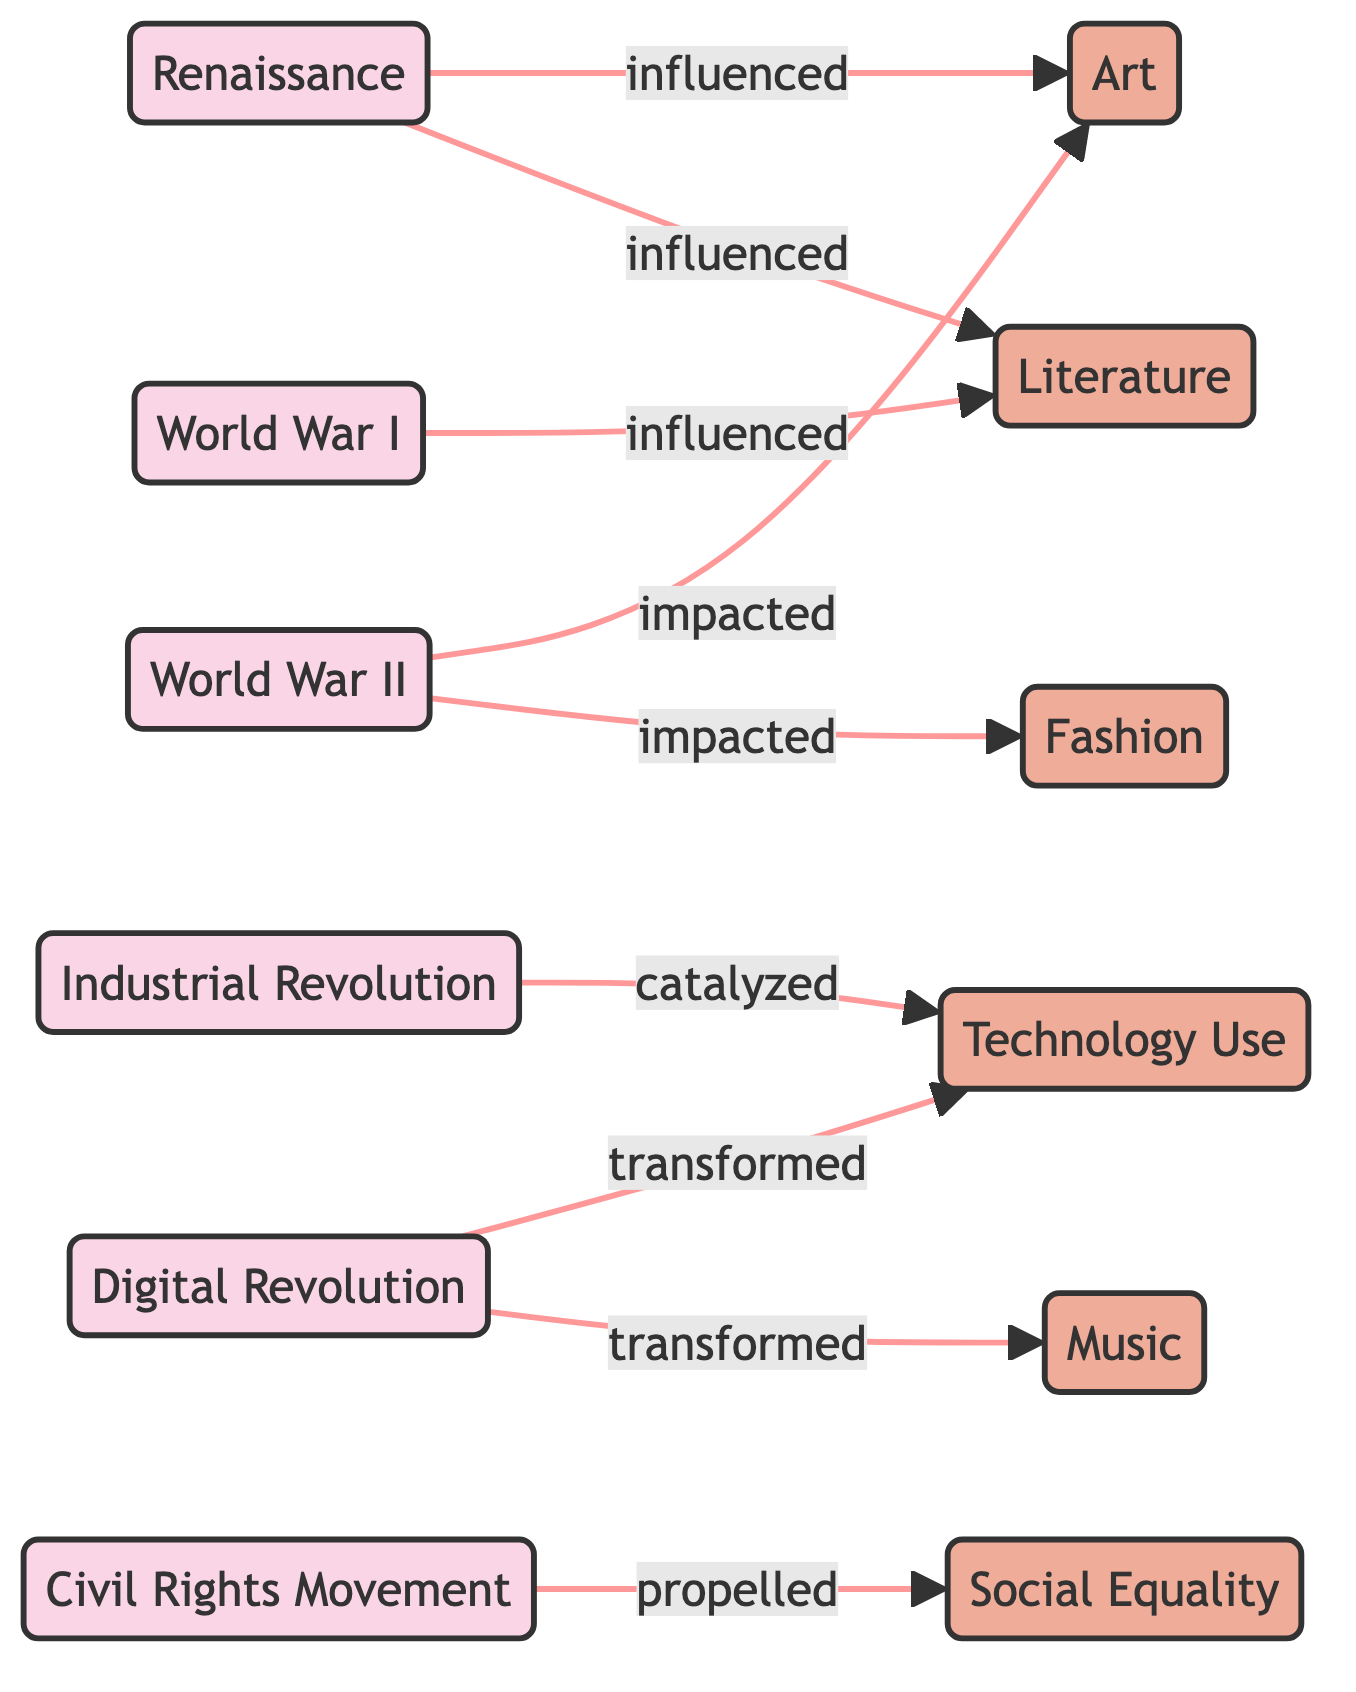What is the total number of nodes in the diagram? The diagram contains 12 nodes, which includes both historical events and cultural practices. Each unique event and practice is counted as a separate node.
Answer: 12 Which historical event influenced Art? The diagram shows that Renaissance and World War II both have directed edges leading to the Art node, indicating they influenced it.
Answer: Renaissance, World War II How many edges are connected to the Civil Rights Movement? There is one directed edge from the Civil Rights Movement to the Social Equality node, making a total of one connection.
Answer: 1 What are the practices that were impacted by World War II? The directed edges show that both Art and Fashion were impacted by World War II, indicating it influenced these practices.
Answer: Art, Fashion Which event catalyzed Technology Use? According to the diagram, the Industrial Revolution has a directed edge pointing to Technology Use, indicating it catalyzed this practice.
Answer: Industrial Revolution What does the edge from Digital Revolution to Music represent? The edge labeled "transformed" between Digital Revolution and Music indicates that the Digital Revolution significantly changed or altered Music.
Answer: transformed Which event has the most influence on modern cultural practices? Based on the diagram, both Digital Revolution and World War II show multiple influences leading to various modern practices. However, Digital Revolution transforms two practices, suggesting a broad influence.
Answer: Digital Revolution Which cultural practice is a result of multiple historical events? Literature is influenced by both the Renaissance and World War I, indicating it is the result of multiple historical influences seen in the directed edges.
Answer: Literature How many distinct influences does the Digital Revolution have? The Digital Revolution has two distinct influences: one on Technology Use and one on Music, shown by the two directed edges emanating from it.
Answer: 2 